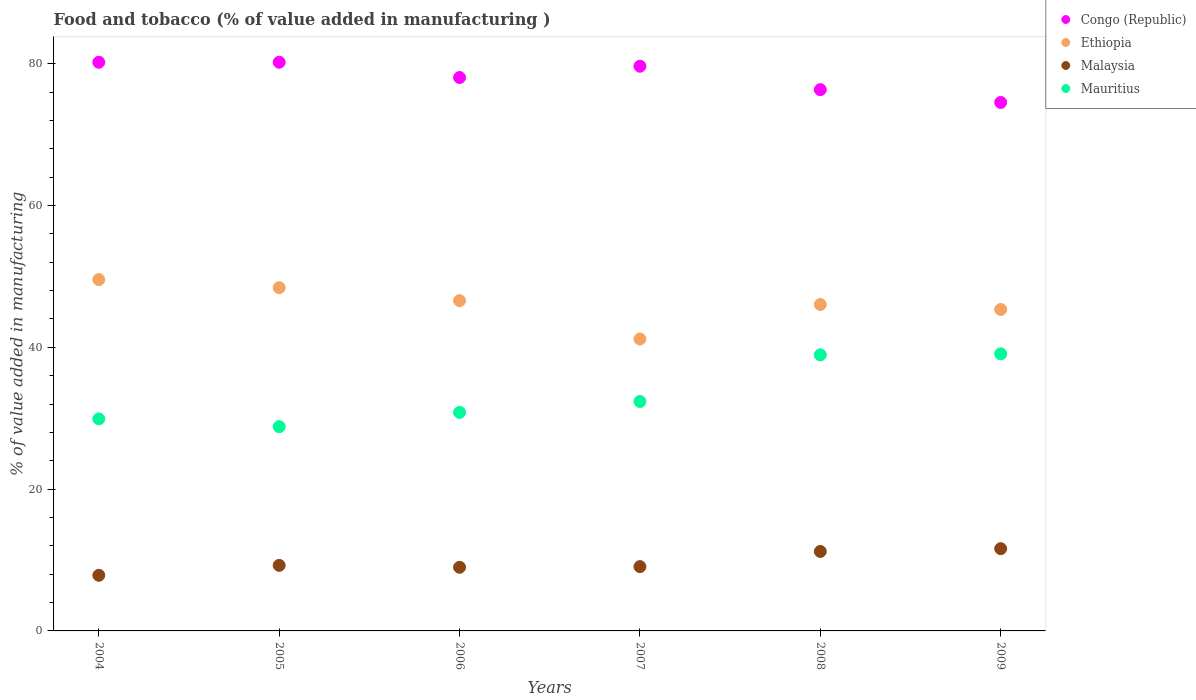How many different coloured dotlines are there?
Give a very brief answer. 4. What is the value added in manufacturing food and tobacco in Ethiopia in 2006?
Offer a terse response. 46.59. Across all years, what is the maximum value added in manufacturing food and tobacco in Malaysia?
Give a very brief answer. 11.6. Across all years, what is the minimum value added in manufacturing food and tobacco in Ethiopia?
Your answer should be compact. 41.18. In which year was the value added in manufacturing food and tobacco in Mauritius maximum?
Offer a terse response. 2009. In which year was the value added in manufacturing food and tobacco in Ethiopia minimum?
Make the answer very short. 2007. What is the total value added in manufacturing food and tobacco in Congo (Republic) in the graph?
Your answer should be very brief. 469.04. What is the difference between the value added in manufacturing food and tobacco in Ethiopia in 2005 and that in 2006?
Offer a terse response. 1.83. What is the difference between the value added in manufacturing food and tobacco in Malaysia in 2006 and the value added in manufacturing food and tobacco in Ethiopia in 2008?
Provide a succinct answer. -37.07. What is the average value added in manufacturing food and tobacco in Malaysia per year?
Ensure brevity in your answer.  9.66. In the year 2008, what is the difference between the value added in manufacturing food and tobacco in Malaysia and value added in manufacturing food and tobacco in Congo (Republic)?
Keep it short and to the point. -65.14. What is the ratio of the value added in manufacturing food and tobacco in Malaysia in 2004 to that in 2005?
Provide a short and direct response. 0.85. Is the value added in manufacturing food and tobacco in Mauritius in 2004 less than that in 2008?
Give a very brief answer. Yes. Is the difference between the value added in manufacturing food and tobacco in Malaysia in 2007 and 2008 greater than the difference between the value added in manufacturing food and tobacco in Congo (Republic) in 2007 and 2008?
Provide a succinct answer. No. What is the difference between the highest and the second highest value added in manufacturing food and tobacco in Congo (Republic)?
Keep it short and to the point. 0.01. What is the difference between the highest and the lowest value added in manufacturing food and tobacco in Ethiopia?
Your answer should be very brief. 8.38. Is it the case that in every year, the sum of the value added in manufacturing food and tobacco in Mauritius and value added in manufacturing food and tobacco in Ethiopia  is greater than the sum of value added in manufacturing food and tobacco in Malaysia and value added in manufacturing food and tobacco in Congo (Republic)?
Your answer should be compact. No. Is it the case that in every year, the sum of the value added in manufacturing food and tobacco in Congo (Republic) and value added in manufacturing food and tobacco in Ethiopia  is greater than the value added in manufacturing food and tobacco in Mauritius?
Offer a very short reply. Yes. Is the value added in manufacturing food and tobacco in Malaysia strictly greater than the value added in manufacturing food and tobacco in Ethiopia over the years?
Your response must be concise. No. How many dotlines are there?
Your answer should be compact. 4. What is the difference between two consecutive major ticks on the Y-axis?
Provide a short and direct response. 20. Are the values on the major ticks of Y-axis written in scientific E-notation?
Provide a succinct answer. No. Does the graph contain any zero values?
Ensure brevity in your answer.  No. How many legend labels are there?
Provide a succinct answer. 4. How are the legend labels stacked?
Give a very brief answer. Vertical. What is the title of the graph?
Keep it short and to the point. Food and tobacco (% of value added in manufacturing ). What is the label or title of the Y-axis?
Your answer should be very brief. % of value added in manufacturing. What is the % of value added in manufacturing in Congo (Republic) in 2004?
Offer a terse response. 80.21. What is the % of value added in manufacturing in Ethiopia in 2004?
Ensure brevity in your answer.  49.56. What is the % of value added in manufacturing in Malaysia in 2004?
Your answer should be very brief. 7.85. What is the % of value added in manufacturing in Mauritius in 2004?
Your response must be concise. 29.91. What is the % of value added in manufacturing of Congo (Republic) in 2005?
Provide a succinct answer. 80.22. What is the % of value added in manufacturing in Ethiopia in 2005?
Keep it short and to the point. 48.41. What is the % of value added in manufacturing of Malaysia in 2005?
Offer a terse response. 9.25. What is the % of value added in manufacturing in Mauritius in 2005?
Provide a succinct answer. 28.81. What is the % of value added in manufacturing in Congo (Republic) in 2006?
Provide a short and direct response. 78.06. What is the % of value added in manufacturing in Ethiopia in 2006?
Make the answer very short. 46.59. What is the % of value added in manufacturing in Malaysia in 2006?
Make the answer very short. 8.98. What is the % of value added in manufacturing in Mauritius in 2006?
Offer a very short reply. 30.82. What is the % of value added in manufacturing in Congo (Republic) in 2007?
Your answer should be very brief. 79.65. What is the % of value added in manufacturing in Ethiopia in 2007?
Provide a succinct answer. 41.18. What is the % of value added in manufacturing in Malaysia in 2007?
Offer a very short reply. 9.07. What is the % of value added in manufacturing of Mauritius in 2007?
Provide a short and direct response. 32.36. What is the % of value added in manufacturing of Congo (Republic) in 2008?
Your answer should be compact. 76.35. What is the % of value added in manufacturing of Ethiopia in 2008?
Offer a very short reply. 46.04. What is the % of value added in manufacturing of Malaysia in 2008?
Provide a short and direct response. 11.21. What is the % of value added in manufacturing in Mauritius in 2008?
Your answer should be very brief. 38.94. What is the % of value added in manufacturing of Congo (Republic) in 2009?
Provide a short and direct response. 74.54. What is the % of value added in manufacturing in Ethiopia in 2009?
Your answer should be very brief. 45.35. What is the % of value added in manufacturing in Malaysia in 2009?
Provide a short and direct response. 11.6. What is the % of value added in manufacturing of Mauritius in 2009?
Make the answer very short. 39.08. Across all years, what is the maximum % of value added in manufacturing in Congo (Republic)?
Your response must be concise. 80.22. Across all years, what is the maximum % of value added in manufacturing in Ethiopia?
Ensure brevity in your answer.  49.56. Across all years, what is the maximum % of value added in manufacturing of Malaysia?
Make the answer very short. 11.6. Across all years, what is the maximum % of value added in manufacturing in Mauritius?
Offer a terse response. 39.08. Across all years, what is the minimum % of value added in manufacturing in Congo (Republic)?
Your answer should be compact. 74.54. Across all years, what is the minimum % of value added in manufacturing of Ethiopia?
Your answer should be very brief. 41.18. Across all years, what is the minimum % of value added in manufacturing of Malaysia?
Offer a very short reply. 7.85. Across all years, what is the minimum % of value added in manufacturing in Mauritius?
Offer a very short reply. 28.81. What is the total % of value added in manufacturing of Congo (Republic) in the graph?
Your answer should be very brief. 469.04. What is the total % of value added in manufacturing of Ethiopia in the graph?
Keep it short and to the point. 277.13. What is the total % of value added in manufacturing of Malaysia in the graph?
Your answer should be very brief. 57.95. What is the total % of value added in manufacturing of Mauritius in the graph?
Give a very brief answer. 199.93. What is the difference between the % of value added in manufacturing in Congo (Republic) in 2004 and that in 2005?
Your answer should be compact. -0.01. What is the difference between the % of value added in manufacturing of Ethiopia in 2004 and that in 2005?
Provide a short and direct response. 1.15. What is the difference between the % of value added in manufacturing in Malaysia in 2004 and that in 2005?
Give a very brief answer. -1.4. What is the difference between the % of value added in manufacturing in Mauritius in 2004 and that in 2005?
Offer a terse response. 1.1. What is the difference between the % of value added in manufacturing in Congo (Republic) in 2004 and that in 2006?
Provide a succinct answer. 2.15. What is the difference between the % of value added in manufacturing in Ethiopia in 2004 and that in 2006?
Offer a terse response. 2.97. What is the difference between the % of value added in manufacturing of Malaysia in 2004 and that in 2006?
Your answer should be compact. -1.13. What is the difference between the % of value added in manufacturing in Mauritius in 2004 and that in 2006?
Keep it short and to the point. -0.91. What is the difference between the % of value added in manufacturing of Congo (Republic) in 2004 and that in 2007?
Make the answer very short. 0.56. What is the difference between the % of value added in manufacturing of Ethiopia in 2004 and that in 2007?
Provide a short and direct response. 8.38. What is the difference between the % of value added in manufacturing in Malaysia in 2004 and that in 2007?
Provide a succinct answer. -1.23. What is the difference between the % of value added in manufacturing in Mauritius in 2004 and that in 2007?
Offer a terse response. -2.45. What is the difference between the % of value added in manufacturing in Congo (Republic) in 2004 and that in 2008?
Provide a short and direct response. 3.86. What is the difference between the % of value added in manufacturing of Ethiopia in 2004 and that in 2008?
Your response must be concise. 3.52. What is the difference between the % of value added in manufacturing of Malaysia in 2004 and that in 2008?
Make the answer very short. -3.36. What is the difference between the % of value added in manufacturing of Mauritius in 2004 and that in 2008?
Ensure brevity in your answer.  -9.03. What is the difference between the % of value added in manufacturing of Congo (Republic) in 2004 and that in 2009?
Keep it short and to the point. 5.67. What is the difference between the % of value added in manufacturing of Ethiopia in 2004 and that in 2009?
Ensure brevity in your answer.  4.21. What is the difference between the % of value added in manufacturing in Malaysia in 2004 and that in 2009?
Offer a terse response. -3.76. What is the difference between the % of value added in manufacturing of Mauritius in 2004 and that in 2009?
Your answer should be compact. -9.17. What is the difference between the % of value added in manufacturing in Congo (Republic) in 2005 and that in 2006?
Ensure brevity in your answer.  2.16. What is the difference between the % of value added in manufacturing of Ethiopia in 2005 and that in 2006?
Your answer should be very brief. 1.83. What is the difference between the % of value added in manufacturing of Malaysia in 2005 and that in 2006?
Offer a terse response. 0.27. What is the difference between the % of value added in manufacturing in Mauritius in 2005 and that in 2006?
Offer a very short reply. -2.01. What is the difference between the % of value added in manufacturing of Congo (Republic) in 2005 and that in 2007?
Offer a very short reply. 0.56. What is the difference between the % of value added in manufacturing of Ethiopia in 2005 and that in 2007?
Give a very brief answer. 7.24. What is the difference between the % of value added in manufacturing in Malaysia in 2005 and that in 2007?
Make the answer very short. 0.17. What is the difference between the % of value added in manufacturing of Mauritius in 2005 and that in 2007?
Offer a terse response. -3.55. What is the difference between the % of value added in manufacturing of Congo (Republic) in 2005 and that in 2008?
Your response must be concise. 3.87. What is the difference between the % of value added in manufacturing in Ethiopia in 2005 and that in 2008?
Your response must be concise. 2.37. What is the difference between the % of value added in manufacturing of Malaysia in 2005 and that in 2008?
Provide a succinct answer. -1.96. What is the difference between the % of value added in manufacturing in Mauritius in 2005 and that in 2008?
Ensure brevity in your answer.  -10.13. What is the difference between the % of value added in manufacturing in Congo (Republic) in 2005 and that in 2009?
Make the answer very short. 5.67. What is the difference between the % of value added in manufacturing in Ethiopia in 2005 and that in 2009?
Provide a short and direct response. 3.07. What is the difference between the % of value added in manufacturing of Malaysia in 2005 and that in 2009?
Provide a succinct answer. -2.36. What is the difference between the % of value added in manufacturing of Mauritius in 2005 and that in 2009?
Provide a short and direct response. -10.27. What is the difference between the % of value added in manufacturing in Congo (Republic) in 2006 and that in 2007?
Provide a short and direct response. -1.59. What is the difference between the % of value added in manufacturing of Ethiopia in 2006 and that in 2007?
Keep it short and to the point. 5.41. What is the difference between the % of value added in manufacturing of Malaysia in 2006 and that in 2007?
Offer a very short reply. -0.1. What is the difference between the % of value added in manufacturing in Mauritius in 2006 and that in 2007?
Offer a terse response. -1.54. What is the difference between the % of value added in manufacturing in Congo (Republic) in 2006 and that in 2008?
Give a very brief answer. 1.71. What is the difference between the % of value added in manufacturing of Ethiopia in 2006 and that in 2008?
Your answer should be very brief. 0.54. What is the difference between the % of value added in manufacturing in Malaysia in 2006 and that in 2008?
Offer a terse response. -2.23. What is the difference between the % of value added in manufacturing in Mauritius in 2006 and that in 2008?
Keep it short and to the point. -8.12. What is the difference between the % of value added in manufacturing of Congo (Republic) in 2006 and that in 2009?
Your answer should be very brief. 3.52. What is the difference between the % of value added in manufacturing of Ethiopia in 2006 and that in 2009?
Make the answer very short. 1.24. What is the difference between the % of value added in manufacturing in Malaysia in 2006 and that in 2009?
Make the answer very short. -2.63. What is the difference between the % of value added in manufacturing in Mauritius in 2006 and that in 2009?
Offer a very short reply. -8.26. What is the difference between the % of value added in manufacturing in Congo (Republic) in 2007 and that in 2008?
Offer a terse response. 3.3. What is the difference between the % of value added in manufacturing of Ethiopia in 2007 and that in 2008?
Your response must be concise. -4.87. What is the difference between the % of value added in manufacturing in Malaysia in 2007 and that in 2008?
Your response must be concise. -2.14. What is the difference between the % of value added in manufacturing of Mauritius in 2007 and that in 2008?
Provide a short and direct response. -6.58. What is the difference between the % of value added in manufacturing in Congo (Republic) in 2007 and that in 2009?
Provide a short and direct response. 5.11. What is the difference between the % of value added in manufacturing in Ethiopia in 2007 and that in 2009?
Give a very brief answer. -4.17. What is the difference between the % of value added in manufacturing of Malaysia in 2007 and that in 2009?
Ensure brevity in your answer.  -2.53. What is the difference between the % of value added in manufacturing in Mauritius in 2007 and that in 2009?
Ensure brevity in your answer.  -6.72. What is the difference between the % of value added in manufacturing of Congo (Republic) in 2008 and that in 2009?
Your answer should be very brief. 1.81. What is the difference between the % of value added in manufacturing in Ethiopia in 2008 and that in 2009?
Offer a terse response. 0.69. What is the difference between the % of value added in manufacturing of Malaysia in 2008 and that in 2009?
Ensure brevity in your answer.  -0.39. What is the difference between the % of value added in manufacturing of Mauritius in 2008 and that in 2009?
Your answer should be very brief. -0.14. What is the difference between the % of value added in manufacturing in Congo (Republic) in 2004 and the % of value added in manufacturing in Ethiopia in 2005?
Give a very brief answer. 31.8. What is the difference between the % of value added in manufacturing of Congo (Republic) in 2004 and the % of value added in manufacturing of Malaysia in 2005?
Provide a short and direct response. 70.97. What is the difference between the % of value added in manufacturing of Congo (Republic) in 2004 and the % of value added in manufacturing of Mauritius in 2005?
Offer a terse response. 51.4. What is the difference between the % of value added in manufacturing in Ethiopia in 2004 and the % of value added in manufacturing in Malaysia in 2005?
Provide a short and direct response. 40.31. What is the difference between the % of value added in manufacturing in Ethiopia in 2004 and the % of value added in manufacturing in Mauritius in 2005?
Your answer should be very brief. 20.75. What is the difference between the % of value added in manufacturing in Malaysia in 2004 and the % of value added in manufacturing in Mauritius in 2005?
Keep it short and to the point. -20.97. What is the difference between the % of value added in manufacturing of Congo (Republic) in 2004 and the % of value added in manufacturing of Ethiopia in 2006?
Provide a succinct answer. 33.63. What is the difference between the % of value added in manufacturing of Congo (Republic) in 2004 and the % of value added in manufacturing of Malaysia in 2006?
Provide a short and direct response. 71.24. What is the difference between the % of value added in manufacturing in Congo (Republic) in 2004 and the % of value added in manufacturing in Mauritius in 2006?
Provide a short and direct response. 49.39. What is the difference between the % of value added in manufacturing of Ethiopia in 2004 and the % of value added in manufacturing of Malaysia in 2006?
Your answer should be very brief. 40.58. What is the difference between the % of value added in manufacturing of Ethiopia in 2004 and the % of value added in manufacturing of Mauritius in 2006?
Offer a terse response. 18.74. What is the difference between the % of value added in manufacturing of Malaysia in 2004 and the % of value added in manufacturing of Mauritius in 2006?
Your answer should be very brief. -22.98. What is the difference between the % of value added in manufacturing of Congo (Republic) in 2004 and the % of value added in manufacturing of Ethiopia in 2007?
Ensure brevity in your answer.  39.03. What is the difference between the % of value added in manufacturing in Congo (Republic) in 2004 and the % of value added in manufacturing in Malaysia in 2007?
Provide a succinct answer. 71.14. What is the difference between the % of value added in manufacturing in Congo (Republic) in 2004 and the % of value added in manufacturing in Mauritius in 2007?
Ensure brevity in your answer.  47.85. What is the difference between the % of value added in manufacturing in Ethiopia in 2004 and the % of value added in manufacturing in Malaysia in 2007?
Make the answer very short. 40.49. What is the difference between the % of value added in manufacturing of Ethiopia in 2004 and the % of value added in manufacturing of Mauritius in 2007?
Give a very brief answer. 17.2. What is the difference between the % of value added in manufacturing in Malaysia in 2004 and the % of value added in manufacturing in Mauritius in 2007?
Give a very brief answer. -24.52. What is the difference between the % of value added in manufacturing of Congo (Republic) in 2004 and the % of value added in manufacturing of Ethiopia in 2008?
Offer a terse response. 34.17. What is the difference between the % of value added in manufacturing of Congo (Republic) in 2004 and the % of value added in manufacturing of Malaysia in 2008?
Offer a terse response. 69. What is the difference between the % of value added in manufacturing of Congo (Republic) in 2004 and the % of value added in manufacturing of Mauritius in 2008?
Offer a very short reply. 41.27. What is the difference between the % of value added in manufacturing of Ethiopia in 2004 and the % of value added in manufacturing of Malaysia in 2008?
Provide a short and direct response. 38.35. What is the difference between the % of value added in manufacturing in Ethiopia in 2004 and the % of value added in manufacturing in Mauritius in 2008?
Provide a short and direct response. 10.62. What is the difference between the % of value added in manufacturing of Malaysia in 2004 and the % of value added in manufacturing of Mauritius in 2008?
Make the answer very short. -31.1. What is the difference between the % of value added in manufacturing of Congo (Republic) in 2004 and the % of value added in manufacturing of Ethiopia in 2009?
Provide a short and direct response. 34.86. What is the difference between the % of value added in manufacturing of Congo (Republic) in 2004 and the % of value added in manufacturing of Malaysia in 2009?
Ensure brevity in your answer.  68.61. What is the difference between the % of value added in manufacturing in Congo (Republic) in 2004 and the % of value added in manufacturing in Mauritius in 2009?
Your response must be concise. 41.13. What is the difference between the % of value added in manufacturing of Ethiopia in 2004 and the % of value added in manufacturing of Malaysia in 2009?
Your answer should be very brief. 37.96. What is the difference between the % of value added in manufacturing of Ethiopia in 2004 and the % of value added in manufacturing of Mauritius in 2009?
Provide a succinct answer. 10.48. What is the difference between the % of value added in manufacturing in Malaysia in 2004 and the % of value added in manufacturing in Mauritius in 2009?
Make the answer very short. -31.24. What is the difference between the % of value added in manufacturing of Congo (Republic) in 2005 and the % of value added in manufacturing of Ethiopia in 2006?
Provide a succinct answer. 33.63. What is the difference between the % of value added in manufacturing in Congo (Republic) in 2005 and the % of value added in manufacturing in Malaysia in 2006?
Your answer should be compact. 71.24. What is the difference between the % of value added in manufacturing in Congo (Republic) in 2005 and the % of value added in manufacturing in Mauritius in 2006?
Keep it short and to the point. 49.39. What is the difference between the % of value added in manufacturing of Ethiopia in 2005 and the % of value added in manufacturing of Malaysia in 2006?
Offer a very short reply. 39.44. What is the difference between the % of value added in manufacturing of Ethiopia in 2005 and the % of value added in manufacturing of Mauritius in 2006?
Ensure brevity in your answer.  17.59. What is the difference between the % of value added in manufacturing in Malaysia in 2005 and the % of value added in manufacturing in Mauritius in 2006?
Offer a very short reply. -21.58. What is the difference between the % of value added in manufacturing of Congo (Republic) in 2005 and the % of value added in manufacturing of Ethiopia in 2007?
Your answer should be very brief. 39.04. What is the difference between the % of value added in manufacturing in Congo (Republic) in 2005 and the % of value added in manufacturing in Malaysia in 2007?
Make the answer very short. 71.15. What is the difference between the % of value added in manufacturing of Congo (Republic) in 2005 and the % of value added in manufacturing of Mauritius in 2007?
Make the answer very short. 47.86. What is the difference between the % of value added in manufacturing of Ethiopia in 2005 and the % of value added in manufacturing of Malaysia in 2007?
Give a very brief answer. 39.34. What is the difference between the % of value added in manufacturing in Ethiopia in 2005 and the % of value added in manufacturing in Mauritius in 2007?
Offer a very short reply. 16.05. What is the difference between the % of value added in manufacturing of Malaysia in 2005 and the % of value added in manufacturing of Mauritius in 2007?
Ensure brevity in your answer.  -23.12. What is the difference between the % of value added in manufacturing of Congo (Republic) in 2005 and the % of value added in manufacturing of Ethiopia in 2008?
Offer a terse response. 34.17. What is the difference between the % of value added in manufacturing in Congo (Republic) in 2005 and the % of value added in manufacturing in Malaysia in 2008?
Your answer should be compact. 69.01. What is the difference between the % of value added in manufacturing of Congo (Republic) in 2005 and the % of value added in manufacturing of Mauritius in 2008?
Your answer should be very brief. 41.28. What is the difference between the % of value added in manufacturing in Ethiopia in 2005 and the % of value added in manufacturing in Malaysia in 2008?
Make the answer very short. 37.2. What is the difference between the % of value added in manufacturing in Ethiopia in 2005 and the % of value added in manufacturing in Mauritius in 2008?
Your response must be concise. 9.47. What is the difference between the % of value added in manufacturing in Malaysia in 2005 and the % of value added in manufacturing in Mauritius in 2008?
Offer a terse response. -29.7. What is the difference between the % of value added in manufacturing in Congo (Republic) in 2005 and the % of value added in manufacturing in Ethiopia in 2009?
Give a very brief answer. 34.87. What is the difference between the % of value added in manufacturing of Congo (Republic) in 2005 and the % of value added in manufacturing of Malaysia in 2009?
Keep it short and to the point. 68.62. What is the difference between the % of value added in manufacturing of Congo (Republic) in 2005 and the % of value added in manufacturing of Mauritius in 2009?
Make the answer very short. 41.13. What is the difference between the % of value added in manufacturing of Ethiopia in 2005 and the % of value added in manufacturing of Malaysia in 2009?
Make the answer very short. 36.81. What is the difference between the % of value added in manufacturing in Ethiopia in 2005 and the % of value added in manufacturing in Mauritius in 2009?
Offer a terse response. 9.33. What is the difference between the % of value added in manufacturing in Malaysia in 2005 and the % of value added in manufacturing in Mauritius in 2009?
Keep it short and to the point. -29.84. What is the difference between the % of value added in manufacturing in Congo (Republic) in 2006 and the % of value added in manufacturing in Ethiopia in 2007?
Ensure brevity in your answer.  36.88. What is the difference between the % of value added in manufacturing in Congo (Republic) in 2006 and the % of value added in manufacturing in Malaysia in 2007?
Provide a succinct answer. 68.99. What is the difference between the % of value added in manufacturing in Congo (Republic) in 2006 and the % of value added in manufacturing in Mauritius in 2007?
Your answer should be compact. 45.7. What is the difference between the % of value added in manufacturing of Ethiopia in 2006 and the % of value added in manufacturing of Malaysia in 2007?
Keep it short and to the point. 37.51. What is the difference between the % of value added in manufacturing in Ethiopia in 2006 and the % of value added in manufacturing in Mauritius in 2007?
Ensure brevity in your answer.  14.22. What is the difference between the % of value added in manufacturing in Malaysia in 2006 and the % of value added in manufacturing in Mauritius in 2007?
Offer a terse response. -23.39. What is the difference between the % of value added in manufacturing of Congo (Republic) in 2006 and the % of value added in manufacturing of Ethiopia in 2008?
Ensure brevity in your answer.  32.02. What is the difference between the % of value added in manufacturing in Congo (Republic) in 2006 and the % of value added in manufacturing in Malaysia in 2008?
Offer a terse response. 66.85. What is the difference between the % of value added in manufacturing of Congo (Republic) in 2006 and the % of value added in manufacturing of Mauritius in 2008?
Ensure brevity in your answer.  39.12. What is the difference between the % of value added in manufacturing of Ethiopia in 2006 and the % of value added in manufacturing of Malaysia in 2008?
Your response must be concise. 35.38. What is the difference between the % of value added in manufacturing in Ethiopia in 2006 and the % of value added in manufacturing in Mauritius in 2008?
Your response must be concise. 7.64. What is the difference between the % of value added in manufacturing in Malaysia in 2006 and the % of value added in manufacturing in Mauritius in 2008?
Make the answer very short. -29.97. What is the difference between the % of value added in manufacturing in Congo (Republic) in 2006 and the % of value added in manufacturing in Ethiopia in 2009?
Offer a terse response. 32.71. What is the difference between the % of value added in manufacturing of Congo (Republic) in 2006 and the % of value added in manufacturing of Malaysia in 2009?
Keep it short and to the point. 66.46. What is the difference between the % of value added in manufacturing of Congo (Republic) in 2006 and the % of value added in manufacturing of Mauritius in 2009?
Offer a terse response. 38.98. What is the difference between the % of value added in manufacturing in Ethiopia in 2006 and the % of value added in manufacturing in Malaysia in 2009?
Ensure brevity in your answer.  34.98. What is the difference between the % of value added in manufacturing of Ethiopia in 2006 and the % of value added in manufacturing of Mauritius in 2009?
Keep it short and to the point. 7.5. What is the difference between the % of value added in manufacturing in Malaysia in 2006 and the % of value added in manufacturing in Mauritius in 2009?
Keep it short and to the point. -30.11. What is the difference between the % of value added in manufacturing in Congo (Republic) in 2007 and the % of value added in manufacturing in Ethiopia in 2008?
Offer a very short reply. 33.61. What is the difference between the % of value added in manufacturing of Congo (Republic) in 2007 and the % of value added in manufacturing of Malaysia in 2008?
Your answer should be compact. 68.44. What is the difference between the % of value added in manufacturing of Congo (Republic) in 2007 and the % of value added in manufacturing of Mauritius in 2008?
Make the answer very short. 40.71. What is the difference between the % of value added in manufacturing in Ethiopia in 2007 and the % of value added in manufacturing in Malaysia in 2008?
Make the answer very short. 29.97. What is the difference between the % of value added in manufacturing in Ethiopia in 2007 and the % of value added in manufacturing in Mauritius in 2008?
Make the answer very short. 2.24. What is the difference between the % of value added in manufacturing in Malaysia in 2007 and the % of value added in manufacturing in Mauritius in 2008?
Provide a short and direct response. -29.87. What is the difference between the % of value added in manufacturing in Congo (Republic) in 2007 and the % of value added in manufacturing in Ethiopia in 2009?
Keep it short and to the point. 34.31. What is the difference between the % of value added in manufacturing in Congo (Republic) in 2007 and the % of value added in manufacturing in Malaysia in 2009?
Give a very brief answer. 68.05. What is the difference between the % of value added in manufacturing in Congo (Republic) in 2007 and the % of value added in manufacturing in Mauritius in 2009?
Your answer should be compact. 40.57. What is the difference between the % of value added in manufacturing in Ethiopia in 2007 and the % of value added in manufacturing in Malaysia in 2009?
Offer a very short reply. 29.58. What is the difference between the % of value added in manufacturing in Ethiopia in 2007 and the % of value added in manufacturing in Mauritius in 2009?
Make the answer very short. 2.09. What is the difference between the % of value added in manufacturing in Malaysia in 2007 and the % of value added in manufacturing in Mauritius in 2009?
Keep it short and to the point. -30.01. What is the difference between the % of value added in manufacturing in Congo (Republic) in 2008 and the % of value added in manufacturing in Ethiopia in 2009?
Give a very brief answer. 31. What is the difference between the % of value added in manufacturing of Congo (Republic) in 2008 and the % of value added in manufacturing of Malaysia in 2009?
Your answer should be compact. 64.75. What is the difference between the % of value added in manufacturing of Congo (Republic) in 2008 and the % of value added in manufacturing of Mauritius in 2009?
Make the answer very short. 37.27. What is the difference between the % of value added in manufacturing of Ethiopia in 2008 and the % of value added in manufacturing of Malaysia in 2009?
Keep it short and to the point. 34.44. What is the difference between the % of value added in manufacturing of Ethiopia in 2008 and the % of value added in manufacturing of Mauritius in 2009?
Offer a terse response. 6.96. What is the difference between the % of value added in manufacturing of Malaysia in 2008 and the % of value added in manufacturing of Mauritius in 2009?
Keep it short and to the point. -27.87. What is the average % of value added in manufacturing in Congo (Republic) per year?
Offer a very short reply. 78.17. What is the average % of value added in manufacturing in Ethiopia per year?
Ensure brevity in your answer.  46.19. What is the average % of value added in manufacturing of Malaysia per year?
Give a very brief answer. 9.66. What is the average % of value added in manufacturing of Mauritius per year?
Your answer should be compact. 33.32. In the year 2004, what is the difference between the % of value added in manufacturing in Congo (Republic) and % of value added in manufacturing in Ethiopia?
Keep it short and to the point. 30.65. In the year 2004, what is the difference between the % of value added in manufacturing of Congo (Republic) and % of value added in manufacturing of Malaysia?
Keep it short and to the point. 72.37. In the year 2004, what is the difference between the % of value added in manufacturing in Congo (Republic) and % of value added in manufacturing in Mauritius?
Provide a succinct answer. 50.3. In the year 2004, what is the difference between the % of value added in manufacturing in Ethiopia and % of value added in manufacturing in Malaysia?
Your answer should be very brief. 41.71. In the year 2004, what is the difference between the % of value added in manufacturing of Ethiopia and % of value added in manufacturing of Mauritius?
Your answer should be compact. 19.65. In the year 2004, what is the difference between the % of value added in manufacturing of Malaysia and % of value added in manufacturing of Mauritius?
Offer a very short reply. -22.06. In the year 2005, what is the difference between the % of value added in manufacturing of Congo (Republic) and % of value added in manufacturing of Ethiopia?
Keep it short and to the point. 31.8. In the year 2005, what is the difference between the % of value added in manufacturing in Congo (Republic) and % of value added in manufacturing in Malaysia?
Provide a succinct answer. 70.97. In the year 2005, what is the difference between the % of value added in manufacturing in Congo (Republic) and % of value added in manufacturing in Mauritius?
Offer a terse response. 51.41. In the year 2005, what is the difference between the % of value added in manufacturing in Ethiopia and % of value added in manufacturing in Malaysia?
Keep it short and to the point. 39.17. In the year 2005, what is the difference between the % of value added in manufacturing of Ethiopia and % of value added in manufacturing of Mauritius?
Offer a very short reply. 19.6. In the year 2005, what is the difference between the % of value added in manufacturing of Malaysia and % of value added in manufacturing of Mauritius?
Your response must be concise. -19.57. In the year 2006, what is the difference between the % of value added in manufacturing of Congo (Republic) and % of value added in manufacturing of Ethiopia?
Provide a succinct answer. 31.48. In the year 2006, what is the difference between the % of value added in manufacturing of Congo (Republic) and % of value added in manufacturing of Malaysia?
Provide a succinct answer. 69.09. In the year 2006, what is the difference between the % of value added in manufacturing in Congo (Republic) and % of value added in manufacturing in Mauritius?
Your response must be concise. 47.24. In the year 2006, what is the difference between the % of value added in manufacturing of Ethiopia and % of value added in manufacturing of Malaysia?
Provide a short and direct response. 37.61. In the year 2006, what is the difference between the % of value added in manufacturing of Ethiopia and % of value added in manufacturing of Mauritius?
Provide a succinct answer. 15.76. In the year 2006, what is the difference between the % of value added in manufacturing in Malaysia and % of value added in manufacturing in Mauritius?
Give a very brief answer. -21.85. In the year 2007, what is the difference between the % of value added in manufacturing in Congo (Republic) and % of value added in manufacturing in Ethiopia?
Provide a short and direct response. 38.48. In the year 2007, what is the difference between the % of value added in manufacturing in Congo (Republic) and % of value added in manufacturing in Malaysia?
Provide a succinct answer. 70.58. In the year 2007, what is the difference between the % of value added in manufacturing of Congo (Republic) and % of value added in manufacturing of Mauritius?
Offer a terse response. 47.29. In the year 2007, what is the difference between the % of value added in manufacturing of Ethiopia and % of value added in manufacturing of Malaysia?
Offer a very short reply. 32.11. In the year 2007, what is the difference between the % of value added in manufacturing of Ethiopia and % of value added in manufacturing of Mauritius?
Offer a terse response. 8.82. In the year 2007, what is the difference between the % of value added in manufacturing in Malaysia and % of value added in manufacturing in Mauritius?
Offer a terse response. -23.29. In the year 2008, what is the difference between the % of value added in manufacturing of Congo (Republic) and % of value added in manufacturing of Ethiopia?
Give a very brief answer. 30.31. In the year 2008, what is the difference between the % of value added in manufacturing of Congo (Republic) and % of value added in manufacturing of Malaysia?
Provide a succinct answer. 65.14. In the year 2008, what is the difference between the % of value added in manufacturing in Congo (Republic) and % of value added in manufacturing in Mauritius?
Provide a succinct answer. 37.41. In the year 2008, what is the difference between the % of value added in manufacturing in Ethiopia and % of value added in manufacturing in Malaysia?
Ensure brevity in your answer.  34.83. In the year 2008, what is the difference between the % of value added in manufacturing of Ethiopia and % of value added in manufacturing of Mauritius?
Give a very brief answer. 7.1. In the year 2008, what is the difference between the % of value added in manufacturing of Malaysia and % of value added in manufacturing of Mauritius?
Make the answer very short. -27.73. In the year 2009, what is the difference between the % of value added in manufacturing of Congo (Republic) and % of value added in manufacturing of Ethiopia?
Your answer should be compact. 29.2. In the year 2009, what is the difference between the % of value added in manufacturing of Congo (Republic) and % of value added in manufacturing of Malaysia?
Provide a succinct answer. 62.94. In the year 2009, what is the difference between the % of value added in manufacturing of Congo (Republic) and % of value added in manufacturing of Mauritius?
Offer a terse response. 35.46. In the year 2009, what is the difference between the % of value added in manufacturing in Ethiopia and % of value added in manufacturing in Malaysia?
Offer a terse response. 33.75. In the year 2009, what is the difference between the % of value added in manufacturing in Ethiopia and % of value added in manufacturing in Mauritius?
Offer a terse response. 6.26. In the year 2009, what is the difference between the % of value added in manufacturing of Malaysia and % of value added in manufacturing of Mauritius?
Offer a terse response. -27.48. What is the ratio of the % of value added in manufacturing in Ethiopia in 2004 to that in 2005?
Provide a short and direct response. 1.02. What is the ratio of the % of value added in manufacturing of Malaysia in 2004 to that in 2005?
Offer a terse response. 0.85. What is the ratio of the % of value added in manufacturing of Mauritius in 2004 to that in 2005?
Ensure brevity in your answer.  1.04. What is the ratio of the % of value added in manufacturing of Congo (Republic) in 2004 to that in 2006?
Give a very brief answer. 1.03. What is the ratio of the % of value added in manufacturing of Ethiopia in 2004 to that in 2006?
Offer a terse response. 1.06. What is the ratio of the % of value added in manufacturing in Malaysia in 2004 to that in 2006?
Give a very brief answer. 0.87. What is the ratio of the % of value added in manufacturing of Mauritius in 2004 to that in 2006?
Your answer should be very brief. 0.97. What is the ratio of the % of value added in manufacturing of Congo (Republic) in 2004 to that in 2007?
Your answer should be very brief. 1.01. What is the ratio of the % of value added in manufacturing of Ethiopia in 2004 to that in 2007?
Give a very brief answer. 1.2. What is the ratio of the % of value added in manufacturing of Malaysia in 2004 to that in 2007?
Give a very brief answer. 0.86. What is the ratio of the % of value added in manufacturing of Mauritius in 2004 to that in 2007?
Offer a very short reply. 0.92. What is the ratio of the % of value added in manufacturing of Congo (Republic) in 2004 to that in 2008?
Keep it short and to the point. 1.05. What is the ratio of the % of value added in manufacturing in Ethiopia in 2004 to that in 2008?
Provide a short and direct response. 1.08. What is the ratio of the % of value added in manufacturing in Malaysia in 2004 to that in 2008?
Provide a succinct answer. 0.7. What is the ratio of the % of value added in manufacturing of Mauritius in 2004 to that in 2008?
Provide a succinct answer. 0.77. What is the ratio of the % of value added in manufacturing of Congo (Republic) in 2004 to that in 2009?
Offer a terse response. 1.08. What is the ratio of the % of value added in manufacturing of Ethiopia in 2004 to that in 2009?
Provide a short and direct response. 1.09. What is the ratio of the % of value added in manufacturing in Malaysia in 2004 to that in 2009?
Keep it short and to the point. 0.68. What is the ratio of the % of value added in manufacturing in Mauritius in 2004 to that in 2009?
Your answer should be compact. 0.77. What is the ratio of the % of value added in manufacturing in Congo (Republic) in 2005 to that in 2006?
Provide a succinct answer. 1.03. What is the ratio of the % of value added in manufacturing in Ethiopia in 2005 to that in 2006?
Offer a very short reply. 1.04. What is the ratio of the % of value added in manufacturing in Malaysia in 2005 to that in 2006?
Provide a succinct answer. 1.03. What is the ratio of the % of value added in manufacturing of Mauritius in 2005 to that in 2006?
Keep it short and to the point. 0.93. What is the ratio of the % of value added in manufacturing of Congo (Republic) in 2005 to that in 2007?
Offer a terse response. 1.01. What is the ratio of the % of value added in manufacturing in Ethiopia in 2005 to that in 2007?
Your answer should be compact. 1.18. What is the ratio of the % of value added in manufacturing of Malaysia in 2005 to that in 2007?
Ensure brevity in your answer.  1.02. What is the ratio of the % of value added in manufacturing in Mauritius in 2005 to that in 2007?
Your answer should be very brief. 0.89. What is the ratio of the % of value added in manufacturing of Congo (Republic) in 2005 to that in 2008?
Your answer should be compact. 1.05. What is the ratio of the % of value added in manufacturing in Ethiopia in 2005 to that in 2008?
Keep it short and to the point. 1.05. What is the ratio of the % of value added in manufacturing in Malaysia in 2005 to that in 2008?
Make the answer very short. 0.82. What is the ratio of the % of value added in manufacturing in Mauritius in 2005 to that in 2008?
Keep it short and to the point. 0.74. What is the ratio of the % of value added in manufacturing of Congo (Republic) in 2005 to that in 2009?
Make the answer very short. 1.08. What is the ratio of the % of value added in manufacturing in Ethiopia in 2005 to that in 2009?
Ensure brevity in your answer.  1.07. What is the ratio of the % of value added in manufacturing of Malaysia in 2005 to that in 2009?
Your response must be concise. 0.8. What is the ratio of the % of value added in manufacturing of Mauritius in 2005 to that in 2009?
Provide a succinct answer. 0.74. What is the ratio of the % of value added in manufacturing in Congo (Republic) in 2006 to that in 2007?
Give a very brief answer. 0.98. What is the ratio of the % of value added in manufacturing of Ethiopia in 2006 to that in 2007?
Provide a succinct answer. 1.13. What is the ratio of the % of value added in manufacturing of Mauritius in 2006 to that in 2007?
Provide a succinct answer. 0.95. What is the ratio of the % of value added in manufacturing in Congo (Republic) in 2006 to that in 2008?
Offer a terse response. 1.02. What is the ratio of the % of value added in manufacturing in Ethiopia in 2006 to that in 2008?
Provide a short and direct response. 1.01. What is the ratio of the % of value added in manufacturing of Malaysia in 2006 to that in 2008?
Offer a terse response. 0.8. What is the ratio of the % of value added in manufacturing in Mauritius in 2006 to that in 2008?
Keep it short and to the point. 0.79. What is the ratio of the % of value added in manufacturing in Congo (Republic) in 2006 to that in 2009?
Provide a succinct answer. 1.05. What is the ratio of the % of value added in manufacturing in Ethiopia in 2006 to that in 2009?
Keep it short and to the point. 1.03. What is the ratio of the % of value added in manufacturing of Malaysia in 2006 to that in 2009?
Your answer should be very brief. 0.77. What is the ratio of the % of value added in manufacturing of Mauritius in 2006 to that in 2009?
Offer a terse response. 0.79. What is the ratio of the % of value added in manufacturing in Congo (Republic) in 2007 to that in 2008?
Provide a succinct answer. 1.04. What is the ratio of the % of value added in manufacturing in Ethiopia in 2007 to that in 2008?
Make the answer very short. 0.89. What is the ratio of the % of value added in manufacturing of Malaysia in 2007 to that in 2008?
Offer a very short reply. 0.81. What is the ratio of the % of value added in manufacturing in Mauritius in 2007 to that in 2008?
Give a very brief answer. 0.83. What is the ratio of the % of value added in manufacturing of Congo (Republic) in 2007 to that in 2009?
Offer a very short reply. 1.07. What is the ratio of the % of value added in manufacturing of Ethiopia in 2007 to that in 2009?
Make the answer very short. 0.91. What is the ratio of the % of value added in manufacturing of Malaysia in 2007 to that in 2009?
Provide a short and direct response. 0.78. What is the ratio of the % of value added in manufacturing in Mauritius in 2007 to that in 2009?
Offer a very short reply. 0.83. What is the ratio of the % of value added in manufacturing of Congo (Republic) in 2008 to that in 2009?
Your answer should be compact. 1.02. What is the ratio of the % of value added in manufacturing of Ethiopia in 2008 to that in 2009?
Offer a very short reply. 1.02. What is the ratio of the % of value added in manufacturing of Malaysia in 2008 to that in 2009?
Offer a very short reply. 0.97. What is the difference between the highest and the second highest % of value added in manufacturing in Congo (Republic)?
Give a very brief answer. 0.01. What is the difference between the highest and the second highest % of value added in manufacturing in Ethiopia?
Give a very brief answer. 1.15. What is the difference between the highest and the second highest % of value added in manufacturing in Malaysia?
Offer a terse response. 0.39. What is the difference between the highest and the second highest % of value added in manufacturing in Mauritius?
Offer a terse response. 0.14. What is the difference between the highest and the lowest % of value added in manufacturing of Congo (Republic)?
Offer a very short reply. 5.67. What is the difference between the highest and the lowest % of value added in manufacturing of Ethiopia?
Make the answer very short. 8.38. What is the difference between the highest and the lowest % of value added in manufacturing in Malaysia?
Give a very brief answer. 3.76. What is the difference between the highest and the lowest % of value added in manufacturing in Mauritius?
Keep it short and to the point. 10.27. 